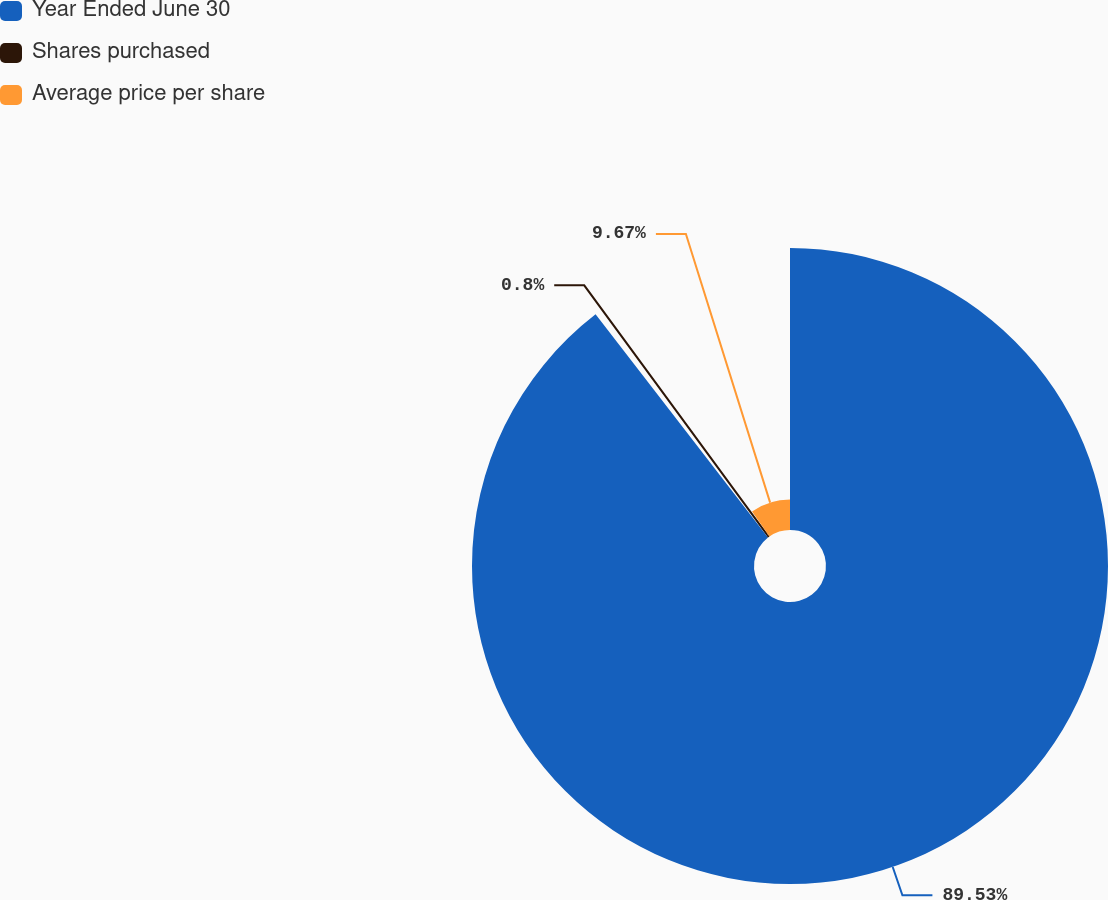<chart> <loc_0><loc_0><loc_500><loc_500><pie_chart><fcel>Year Ended June 30<fcel>Shares purchased<fcel>Average price per share<nl><fcel>89.53%<fcel>0.8%<fcel>9.67%<nl></chart> 